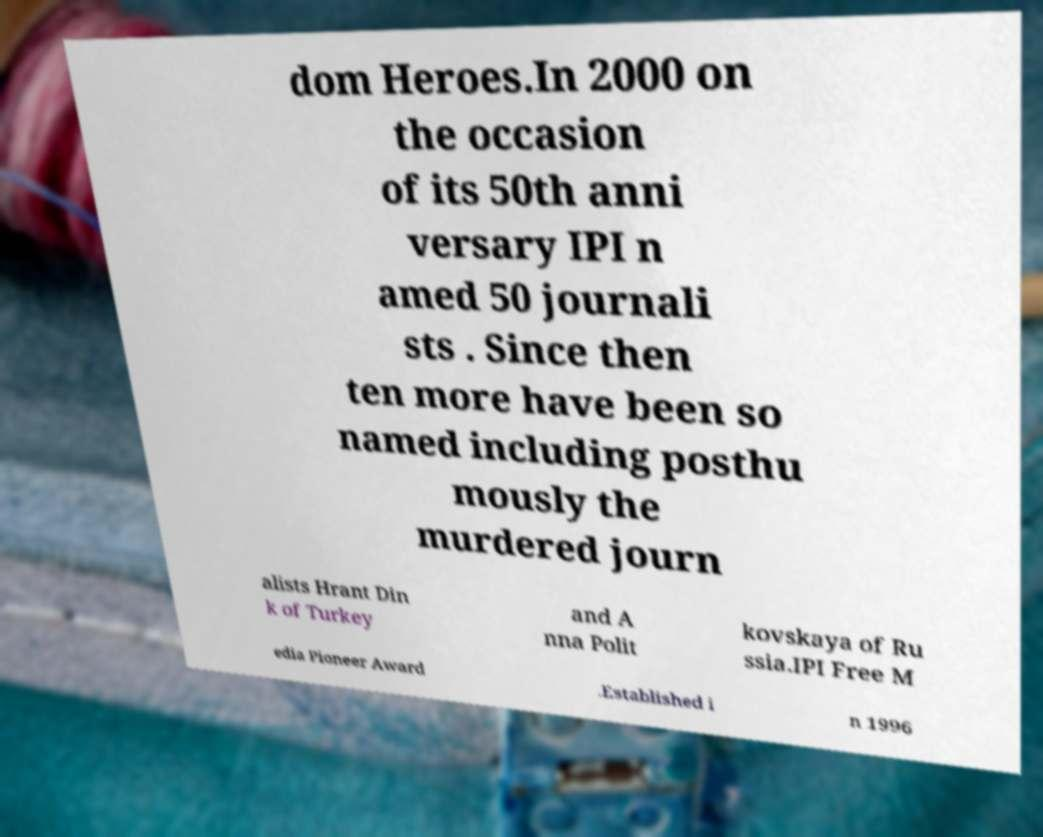Could you extract and type out the text from this image? dom Heroes.In 2000 on the occasion of its 50th anni versary IPI n amed 50 journali sts . Since then ten more have been so named including posthu mously the murdered journ alists Hrant Din k of Turkey and A nna Polit kovskaya of Ru ssia.IPI Free M edia Pioneer Award .Established i n 1996 